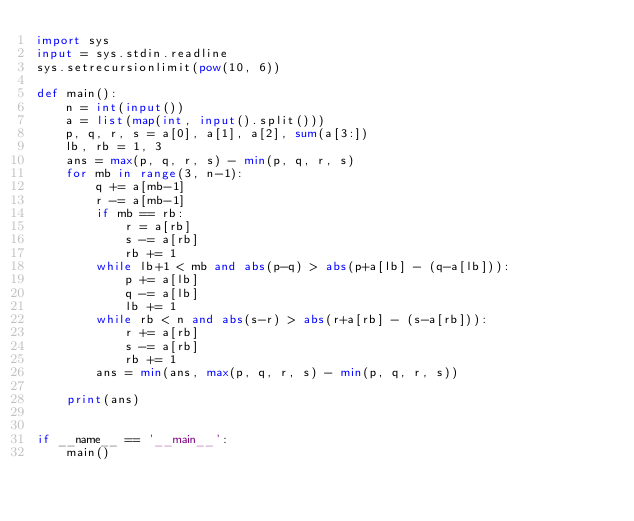Convert code to text. <code><loc_0><loc_0><loc_500><loc_500><_Python_>import sys
input = sys.stdin.readline
sys.setrecursionlimit(pow(10, 6))

def main():
    n = int(input())
    a = list(map(int, input().split()))
    p, q, r, s = a[0], a[1], a[2], sum(a[3:])
    lb, rb = 1, 3
    ans = max(p, q, r, s) - min(p, q, r, s)
    for mb in range(3, n-1):
        q += a[mb-1]
        r -= a[mb-1]
        if mb == rb:
            r = a[rb]
            s -= a[rb]
            rb += 1
        while lb+1 < mb and abs(p-q) > abs(p+a[lb] - (q-a[lb])):
            p += a[lb]
            q -= a[lb]
            lb += 1
        while rb < n and abs(s-r) > abs(r+a[rb] - (s-a[rb])):
            r += a[rb]
            s -= a[rb]
            rb += 1
        ans = min(ans, max(p, q, r, s) - min(p, q, r, s))
            
    print(ans)


if __name__ == '__main__':
    main()
</code> 